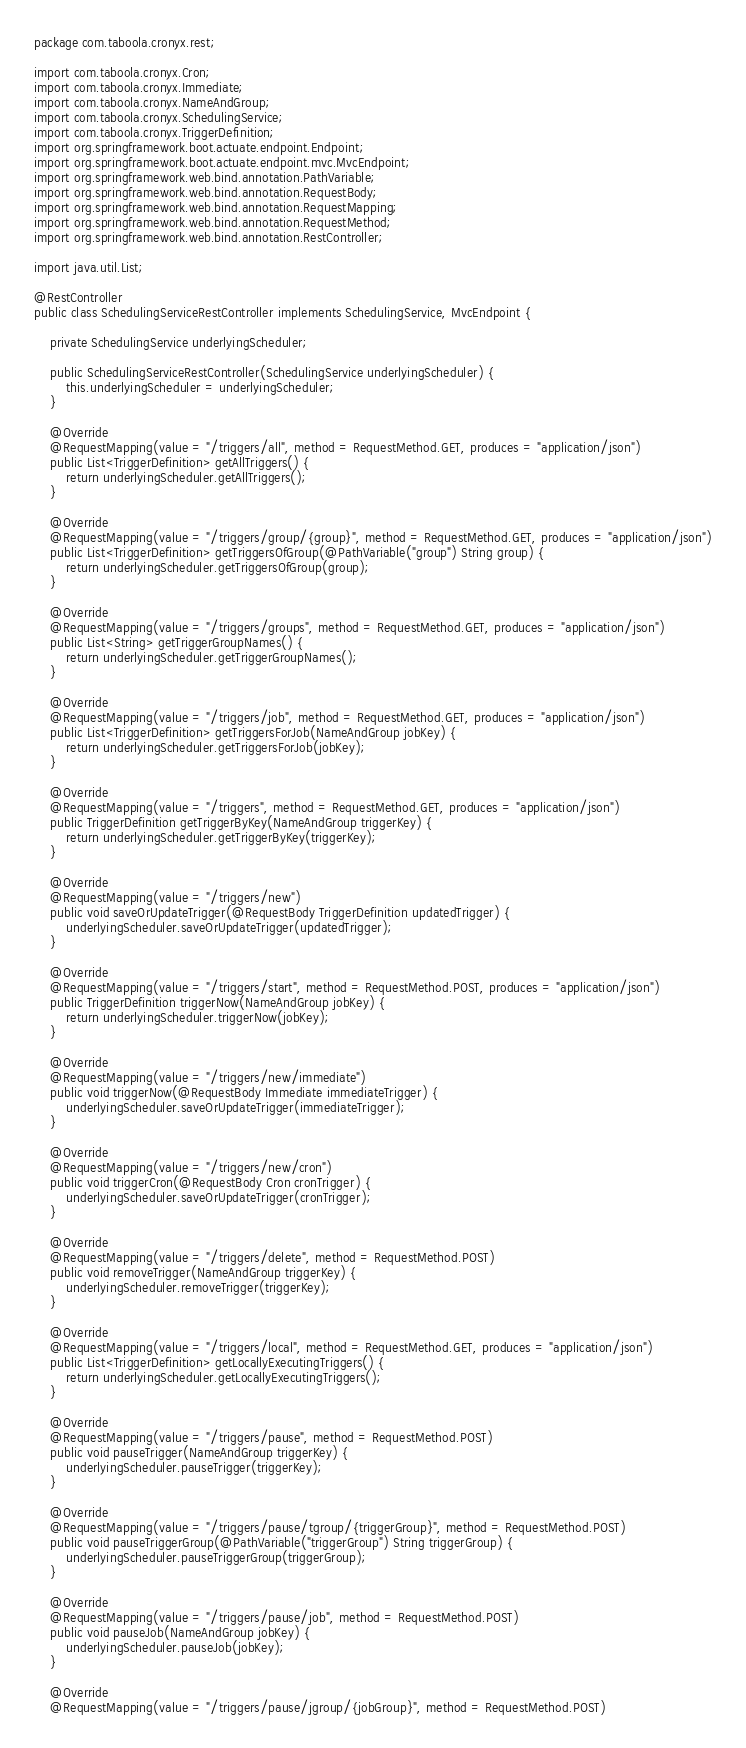Convert code to text. <code><loc_0><loc_0><loc_500><loc_500><_Java_>package com.taboola.cronyx.rest;

import com.taboola.cronyx.Cron;
import com.taboola.cronyx.Immediate;
import com.taboola.cronyx.NameAndGroup;
import com.taboola.cronyx.SchedulingService;
import com.taboola.cronyx.TriggerDefinition;
import org.springframework.boot.actuate.endpoint.Endpoint;
import org.springframework.boot.actuate.endpoint.mvc.MvcEndpoint;
import org.springframework.web.bind.annotation.PathVariable;
import org.springframework.web.bind.annotation.RequestBody;
import org.springframework.web.bind.annotation.RequestMapping;
import org.springframework.web.bind.annotation.RequestMethod;
import org.springframework.web.bind.annotation.RestController;

import java.util.List;

@RestController
public class SchedulingServiceRestController implements SchedulingService, MvcEndpoint {

    private SchedulingService underlyingScheduler;

    public SchedulingServiceRestController(SchedulingService underlyingScheduler) {
        this.underlyingScheduler = underlyingScheduler;
    }

    @Override
    @RequestMapping(value = "/triggers/all", method = RequestMethod.GET, produces = "application/json")
    public List<TriggerDefinition> getAllTriggers() {
        return underlyingScheduler.getAllTriggers();
    }

    @Override
    @RequestMapping(value = "/triggers/group/{group}", method = RequestMethod.GET, produces = "application/json")
    public List<TriggerDefinition> getTriggersOfGroup(@PathVariable("group") String group) {
        return underlyingScheduler.getTriggersOfGroup(group);
    }

    @Override
    @RequestMapping(value = "/triggers/groups", method = RequestMethod.GET, produces = "application/json")
    public List<String> getTriggerGroupNames() {
        return underlyingScheduler.getTriggerGroupNames();
    }

    @Override
    @RequestMapping(value = "/triggers/job", method = RequestMethod.GET, produces = "application/json")
    public List<TriggerDefinition> getTriggersForJob(NameAndGroup jobKey) {
        return underlyingScheduler.getTriggersForJob(jobKey);
    }

    @Override
    @RequestMapping(value = "/triggers", method = RequestMethod.GET, produces = "application/json")
    public TriggerDefinition getTriggerByKey(NameAndGroup triggerKey) {
        return underlyingScheduler.getTriggerByKey(triggerKey);
    }

    @Override
    @RequestMapping(value = "/triggers/new")
    public void saveOrUpdateTrigger(@RequestBody TriggerDefinition updatedTrigger) {
        underlyingScheduler.saveOrUpdateTrigger(updatedTrigger);
    }

    @Override
    @RequestMapping(value = "/triggers/start", method = RequestMethod.POST, produces = "application/json")
    public TriggerDefinition triggerNow(NameAndGroup jobKey) {
        return underlyingScheduler.triggerNow(jobKey);
    }

    @Override
    @RequestMapping(value = "/triggers/new/immediate")
    public void triggerNow(@RequestBody Immediate immediateTrigger) {
        underlyingScheduler.saveOrUpdateTrigger(immediateTrigger);
    }

    @Override
    @RequestMapping(value = "/triggers/new/cron")
    public void triggerCron(@RequestBody Cron cronTrigger) {
        underlyingScheduler.saveOrUpdateTrigger(cronTrigger);
    }

    @Override
    @RequestMapping(value = "/triggers/delete", method = RequestMethod.POST)
    public void removeTrigger(NameAndGroup triggerKey) {
        underlyingScheduler.removeTrigger(triggerKey);
    }

    @Override
    @RequestMapping(value = "/triggers/local", method = RequestMethod.GET, produces = "application/json")
    public List<TriggerDefinition> getLocallyExecutingTriggers() {
        return underlyingScheduler.getLocallyExecutingTriggers();
    }

    @Override
    @RequestMapping(value = "/triggers/pause", method = RequestMethod.POST)
    public void pauseTrigger(NameAndGroup triggerKey) {
        underlyingScheduler.pauseTrigger(triggerKey);
    }

    @Override
    @RequestMapping(value = "/triggers/pause/tgroup/{triggerGroup}", method = RequestMethod.POST)
    public void pauseTriggerGroup(@PathVariable("triggerGroup") String triggerGroup) {
        underlyingScheduler.pauseTriggerGroup(triggerGroup);
    }

    @Override
    @RequestMapping(value = "/triggers/pause/job", method = RequestMethod.POST)
    public void pauseJob(NameAndGroup jobKey) {
        underlyingScheduler.pauseJob(jobKey);
    }

    @Override
    @RequestMapping(value = "/triggers/pause/jgroup/{jobGroup}", method = RequestMethod.POST)</code> 